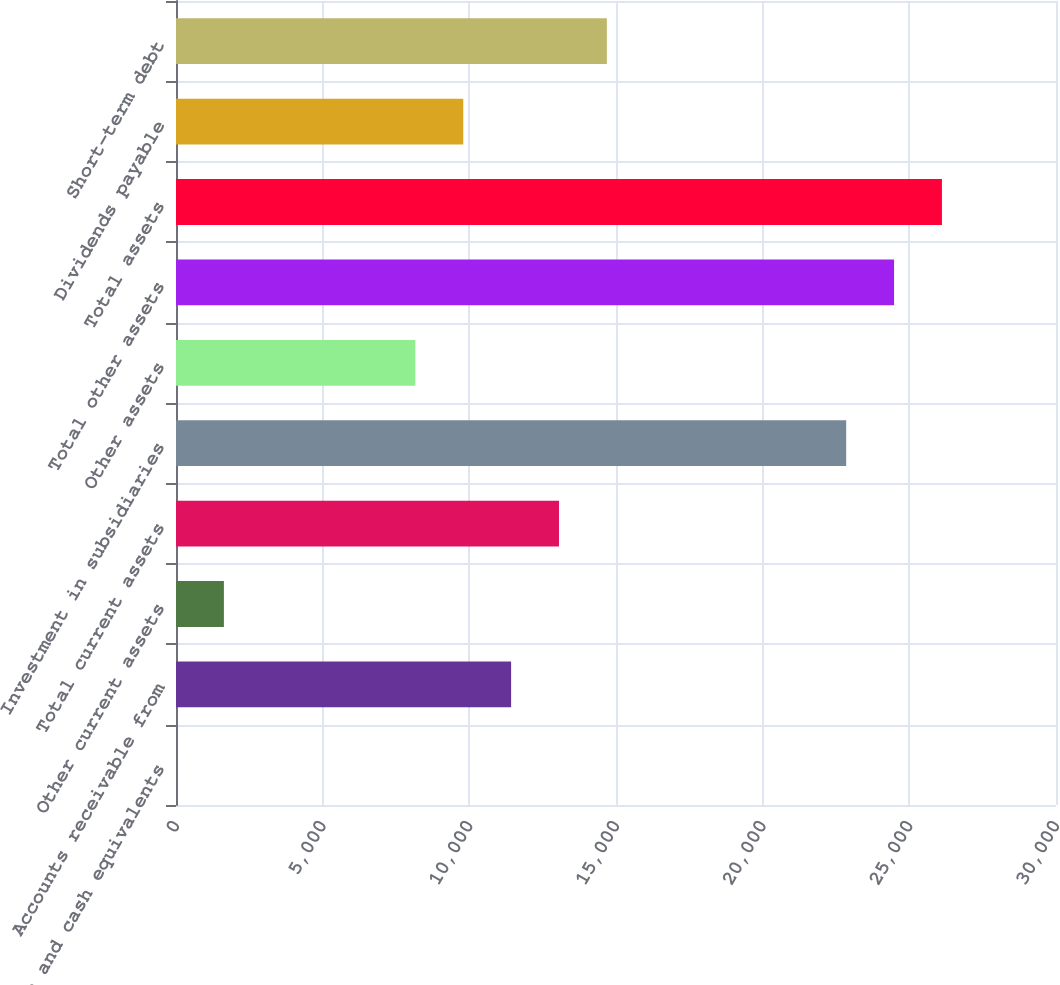Convert chart to OTSL. <chart><loc_0><loc_0><loc_500><loc_500><bar_chart><fcel>Cash and cash equivalents<fcel>Accounts receivable from<fcel>Other current assets<fcel>Total current assets<fcel>Investment in subsidiaries<fcel>Other assets<fcel>Total other assets<fcel>Total assets<fcel>Dividends payable<fcel>Short-term debt<nl><fcel>1<fcel>11424.3<fcel>1632.9<fcel>13056.2<fcel>22847.6<fcel>8160.5<fcel>24479.5<fcel>26111.4<fcel>9792.4<fcel>14688.1<nl></chart> 